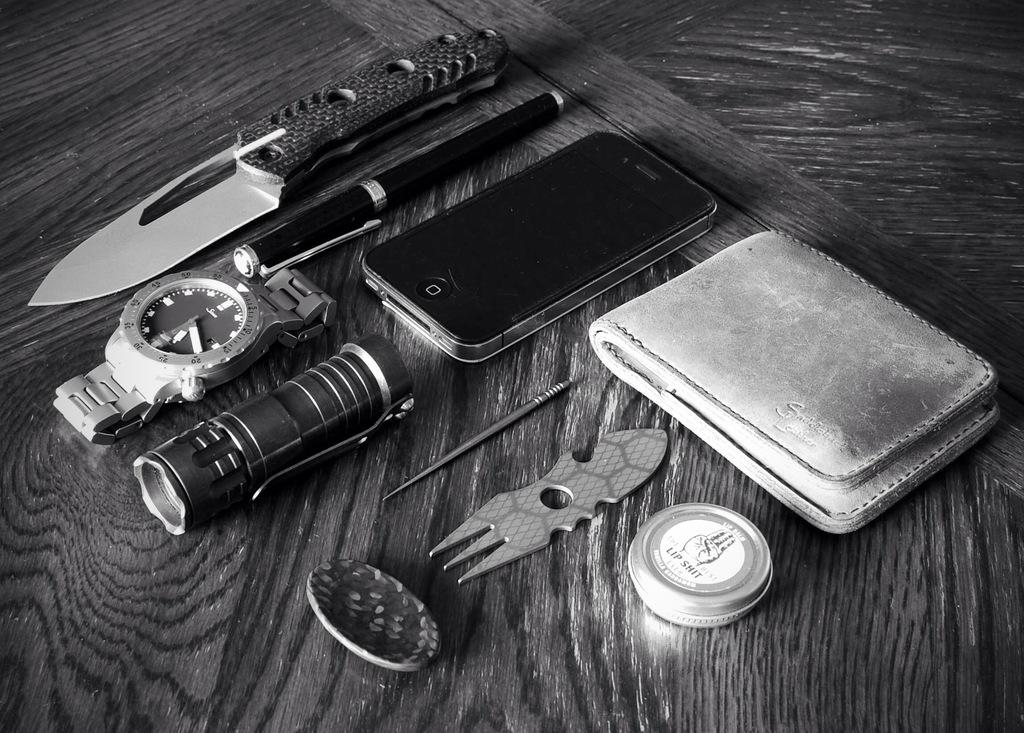<image>
Offer a succinct explanation of the picture presented. A knife, a pen, a watch, a cellphone, a Saddlebacks wallet, and a small container that says Lip Sh*t are among the items displayed. 